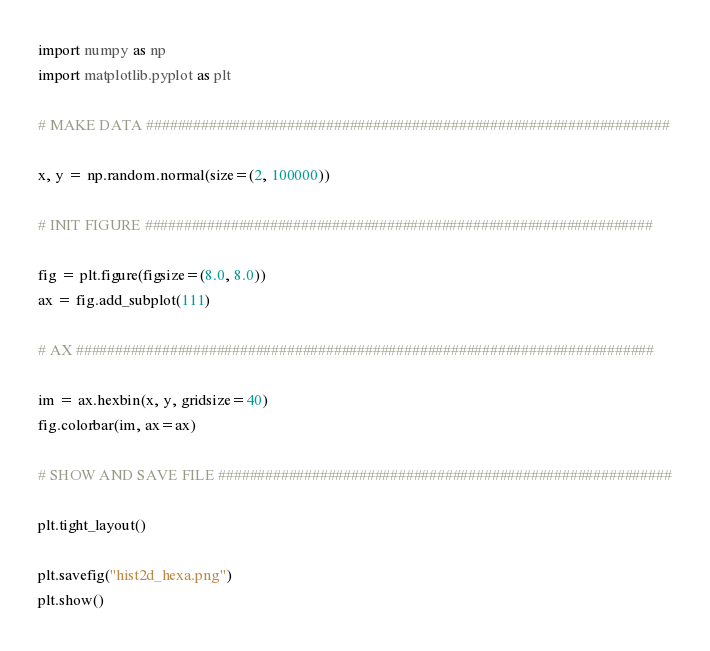<code> <loc_0><loc_0><loc_500><loc_500><_Python_>import numpy as np
import matplotlib.pyplot as plt

# MAKE DATA ###################################################################

x, y = np.random.normal(size=(2, 100000))

# INIT FIGURE #################################################################

fig = plt.figure(figsize=(8.0, 8.0))
ax = fig.add_subplot(111)

# AX ##########################################################################

im = ax.hexbin(x, y, gridsize=40)
fig.colorbar(im, ax=ax)

# SHOW AND SAVE FILE ##########################################################

plt.tight_layout()

plt.savefig("hist2d_hexa.png")
plt.show()
</code> 